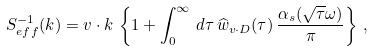Convert formula to latex. <formula><loc_0><loc_0><loc_500><loc_500>S _ { e f f } ^ { - 1 } ( k ) = v \cdot k \, \left \{ 1 + \int _ { 0 } ^ { \infty } \, d \tau \, \widehat { w } _ { v \cdot D } ( \tau ) \, { \frac { \alpha _ { s } ( \sqrt { \tau } \omega ) } { \pi } } \right \} \, ,</formula> 